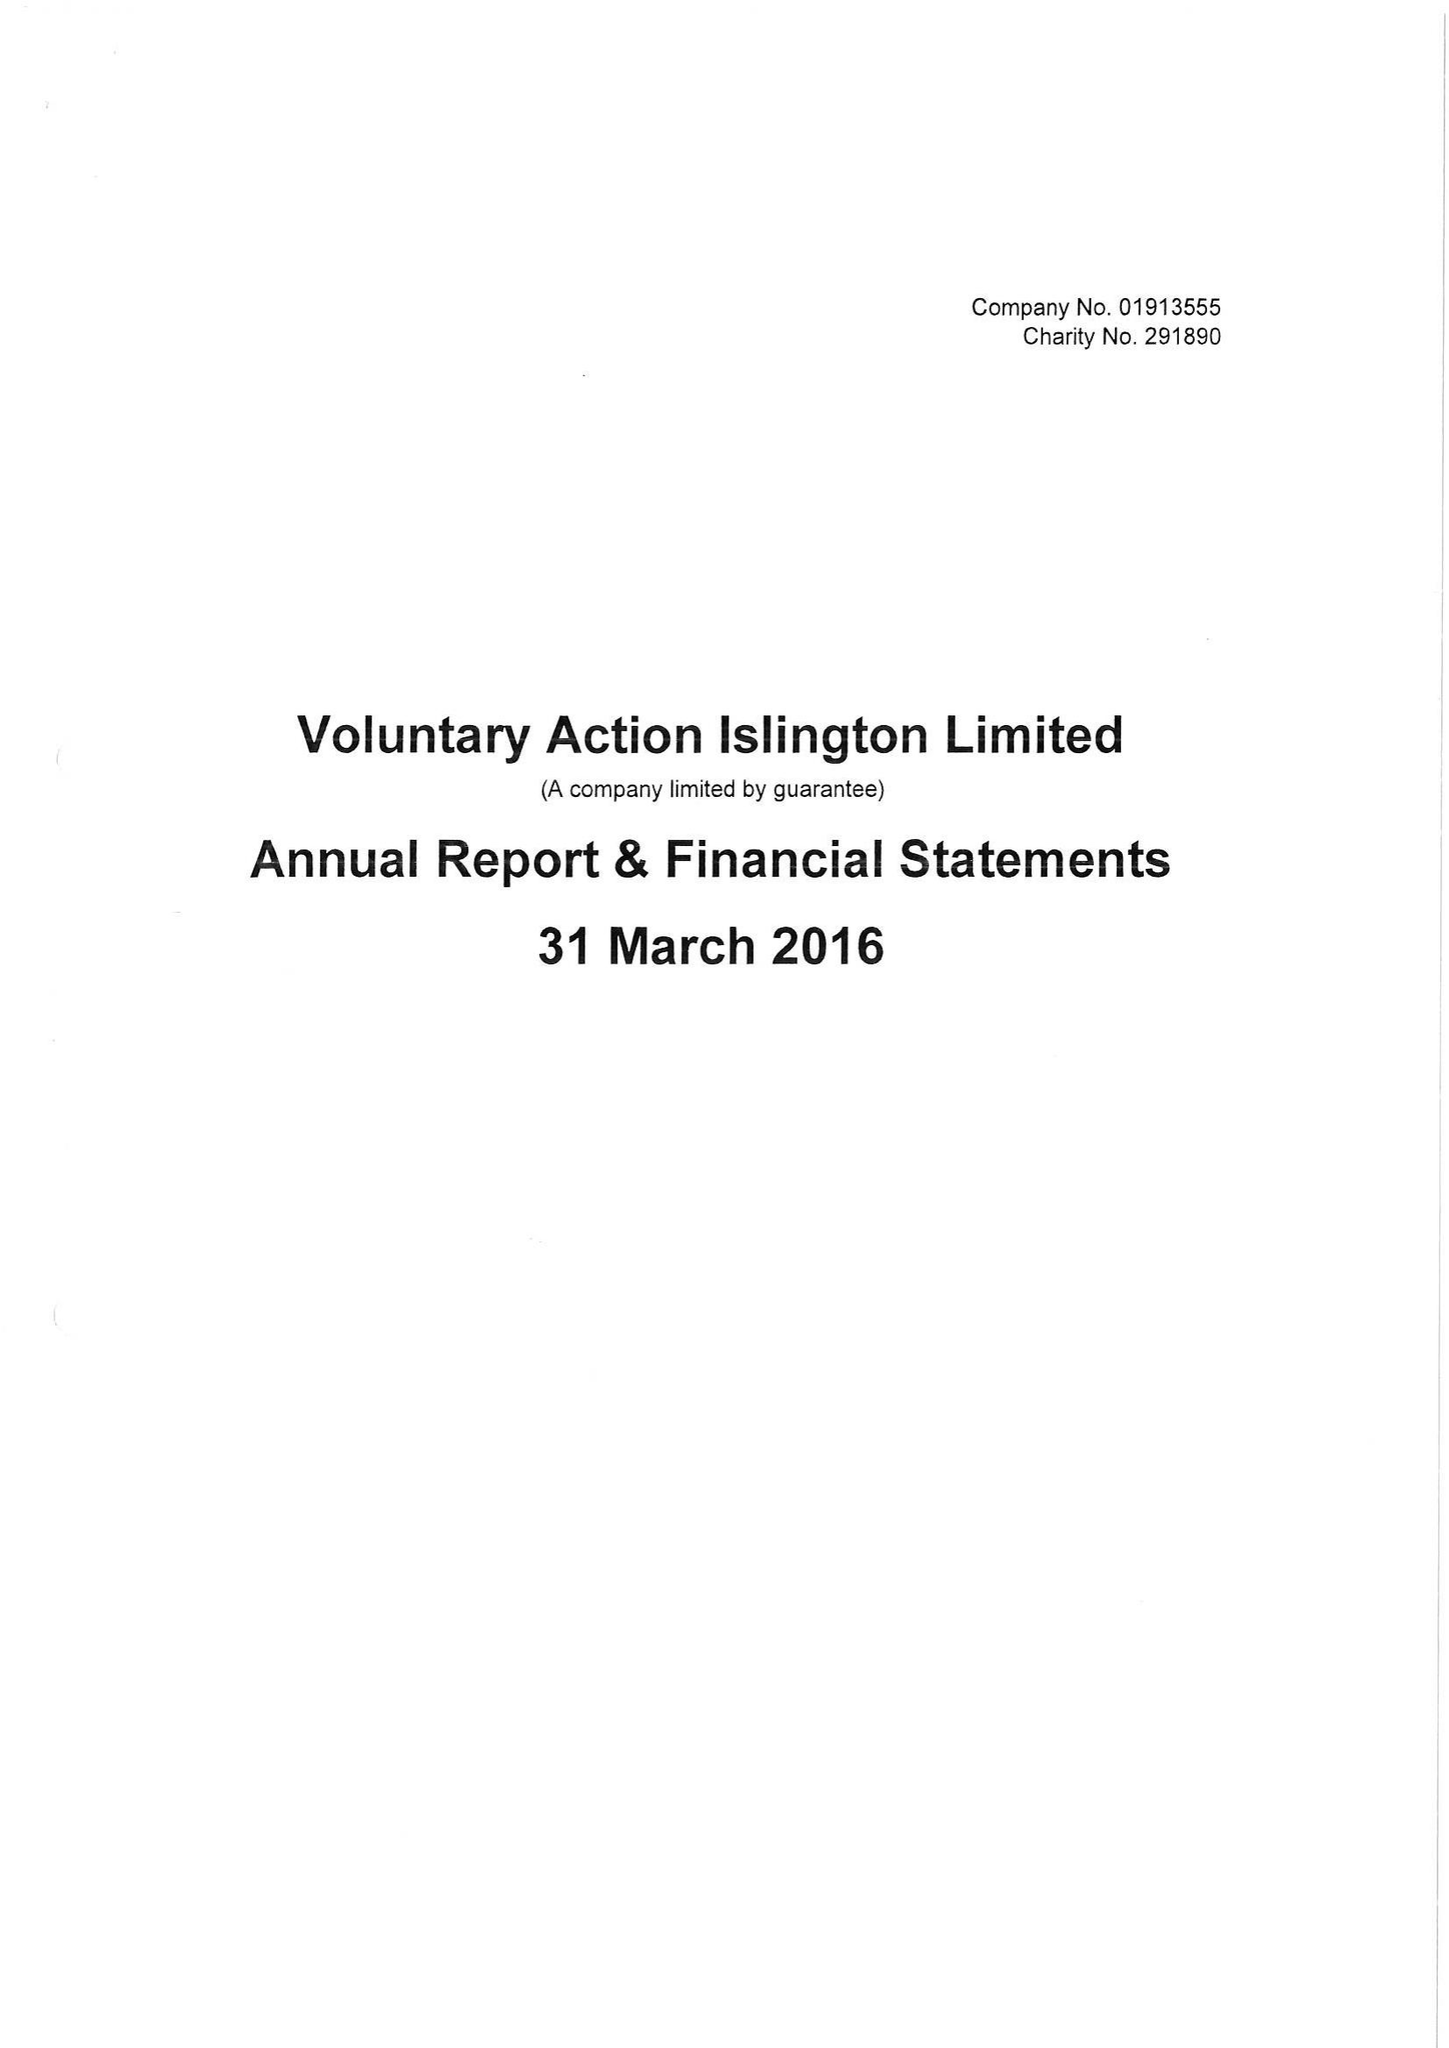What is the value for the spending_annually_in_british_pounds?
Answer the question using a single word or phrase. 535687.00 